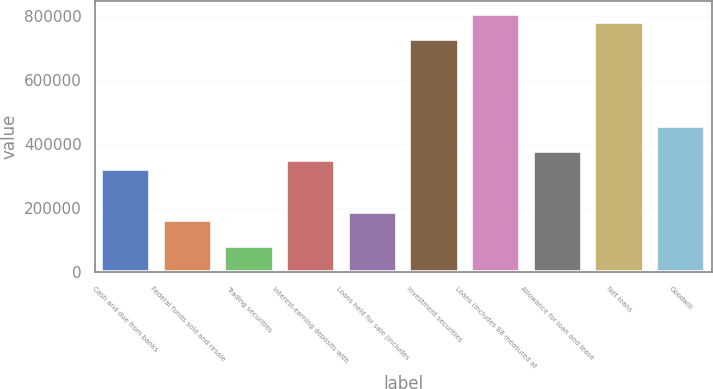Convert chart. <chart><loc_0><loc_0><loc_500><loc_500><bar_chart><fcel>Cash and due from banks<fcel>Federal funds sold and resale<fcel>Trading securities<fcel>Interest-earning deposits with<fcel>Loans held for sale (includes<fcel>Investment securities<fcel>Loans (includes 88 measured at<fcel>Allowance for loan and lease<fcel>Net loans<fcel>Goodwill<nl><fcel>323776<fcel>162036<fcel>81166.1<fcel>350733<fcel>188993<fcel>728127<fcel>808997<fcel>377690<fcel>782040<fcel>458560<nl></chart> 